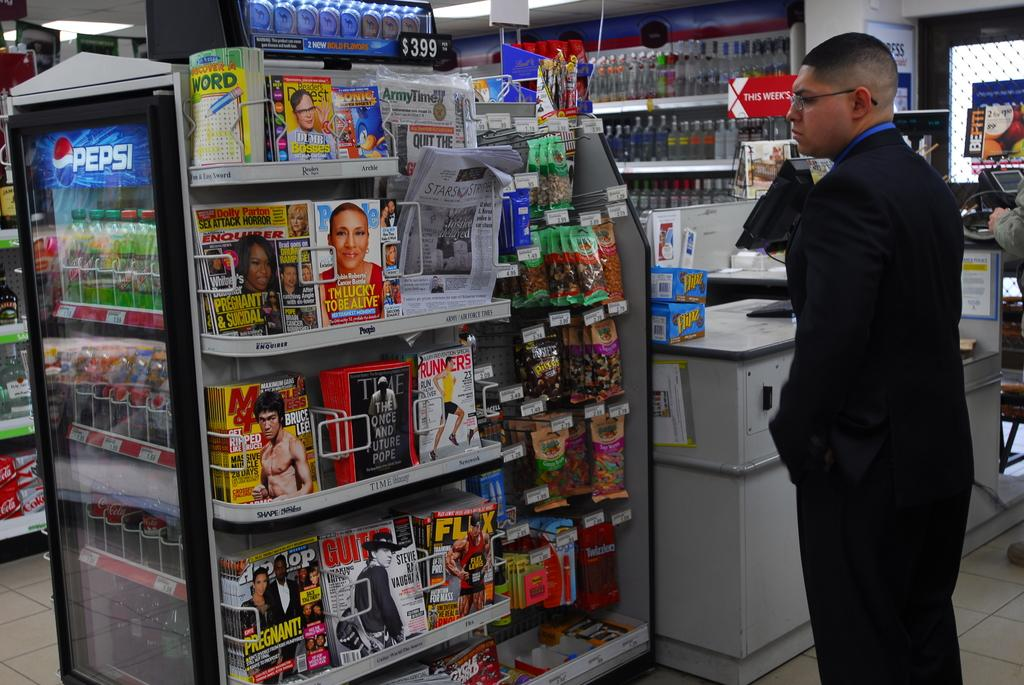<image>
Render a clear and concise summary of the photo. a checkout aisle in a store that has magazines on it with one of them titled 'i'm lucky to be alive' 